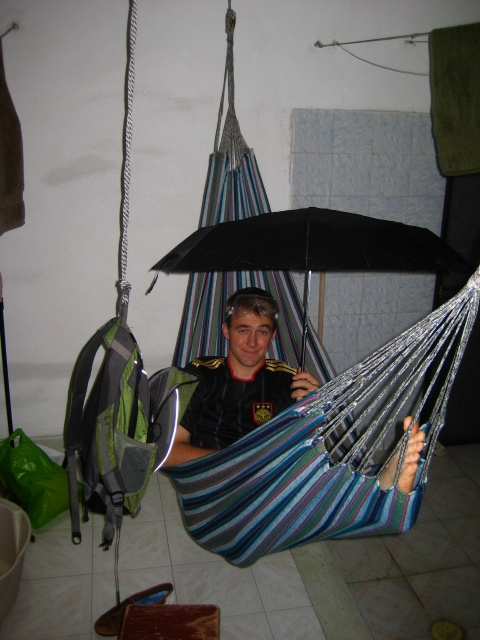Is there a bed frame nearby? No, there is no bed frame visible in the image. The area shown includes only a hammock hanging in a room, with various other items like a backpack and an umbrella, but no bed frame. 